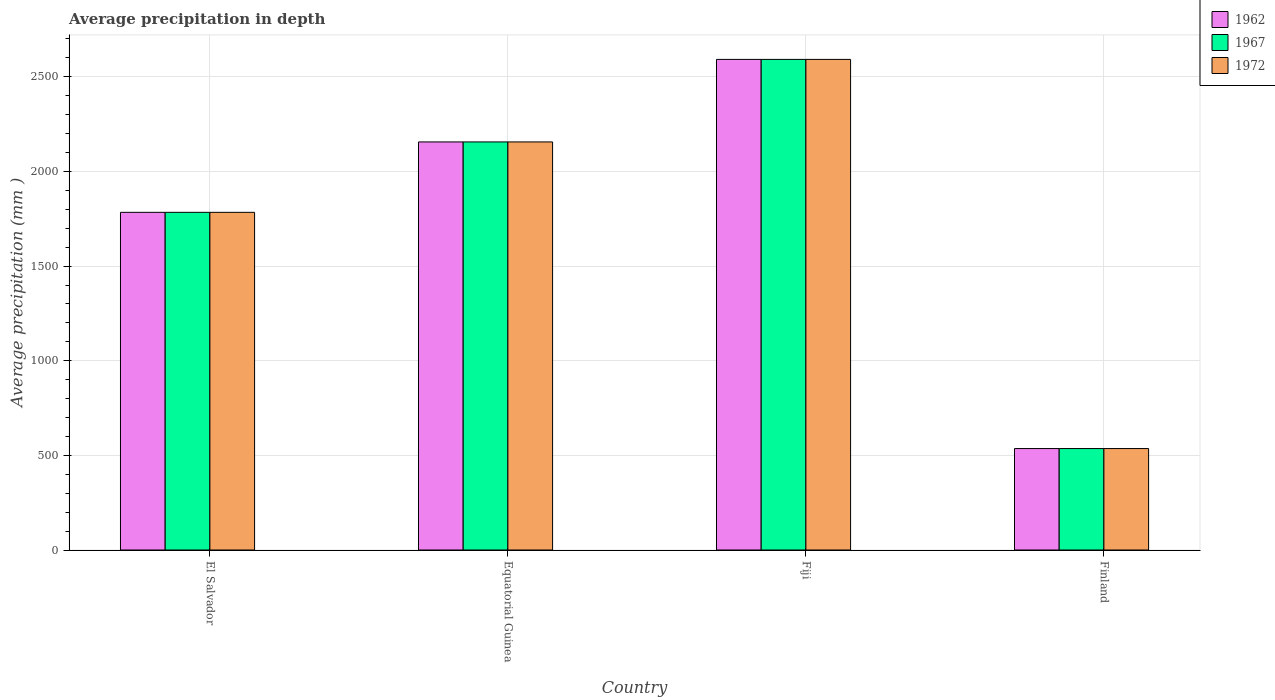How many different coloured bars are there?
Keep it short and to the point. 3. What is the label of the 4th group of bars from the left?
Offer a terse response. Finland. What is the average precipitation in 1972 in El Salvador?
Offer a terse response. 1784. Across all countries, what is the maximum average precipitation in 1962?
Ensure brevity in your answer.  2592. Across all countries, what is the minimum average precipitation in 1972?
Your answer should be compact. 536. In which country was the average precipitation in 1967 maximum?
Provide a succinct answer. Fiji. In which country was the average precipitation in 1962 minimum?
Provide a short and direct response. Finland. What is the total average precipitation in 1967 in the graph?
Offer a terse response. 7068. What is the difference between the average precipitation in 1962 in El Salvador and that in Finland?
Provide a succinct answer. 1248. What is the difference between the average precipitation in 1967 in Fiji and the average precipitation in 1962 in Finland?
Offer a terse response. 2056. What is the average average precipitation in 1972 per country?
Give a very brief answer. 1767. In how many countries, is the average precipitation in 1972 greater than 1400 mm?
Your answer should be very brief. 3. What is the ratio of the average precipitation in 1962 in Equatorial Guinea to that in Finland?
Give a very brief answer. 4.02. Is the difference between the average precipitation in 1967 in Equatorial Guinea and Finland greater than the difference between the average precipitation in 1972 in Equatorial Guinea and Finland?
Keep it short and to the point. No. What is the difference between the highest and the second highest average precipitation in 1972?
Keep it short and to the point. 808. What is the difference between the highest and the lowest average precipitation in 1962?
Your answer should be very brief. 2056. In how many countries, is the average precipitation in 1967 greater than the average average precipitation in 1967 taken over all countries?
Your answer should be compact. 3. What does the 2nd bar from the left in Equatorial Guinea represents?
Offer a terse response. 1967. What does the 3rd bar from the right in Fiji represents?
Your answer should be compact. 1962. Is it the case that in every country, the sum of the average precipitation in 1972 and average precipitation in 1962 is greater than the average precipitation in 1967?
Your response must be concise. Yes. How many bars are there?
Your answer should be very brief. 12. Are the values on the major ticks of Y-axis written in scientific E-notation?
Offer a terse response. No. Does the graph contain any zero values?
Keep it short and to the point. No. Where does the legend appear in the graph?
Your answer should be compact. Top right. How are the legend labels stacked?
Offer a terse response. Vertical. What is the title of the graph?
Offer a very short reply. Average precipitation in depth. What is the label or title of the Y-axis?
Ensure brevity in your answer.  Average precipitation (mm ). What is the Average precipitation (mm ) in 1962 in El Salvador?
Provide a short and direct response. 1784. What is the Average precipitation (mm ) in 1967 in El Salvador?
Make the answer very short. 1784. What is the Average precipitation (mm ) in 1972 in El Salvador?
Your answer should be compact. 1784. What is the Average precipitation (mm ) in 1962 in Equatorial Guinea?
Provide a succinct answer. 2156. What is the Average precipitation (mm ) in 1967 in Equatorial Guinea?
Give a very brief answer. 2156. What is the Average precipitation (mm ) of 1972 in Equatorial Guinea?
Provide a short and direct response. 2156. What is the Average precipitation (mm ) of 1962 in Fiji?
Provide a succinct answer. 2592. What is the Average precipitation (mm ) of 1967 in Fiji?
Your answer should be compact. 2592. What is the Average precipitation (mm ) in 1972 in Fiji?
Give a very brief answer. 2592. What is the Average precipitation (mm ) of 1962 in Finland?
Your answer should be compact. 536. What is the Average precipitation (mm ) in 1967 in Finland?
Make the answer very short. 536. What is the Average precipitation (mm ) of 1972 in Finland?
Your answer should be very brief. 536. Across all countries, what is the maximum Average precipitation (mm ) of 1962?
Ensure brevity in your answer.  2592. Across all countries, what is the maximum Average precipitation (mm ) of 1967?
Provide a succinct answer. 2592. Across all countries, what is the maximum Average precipitation (mm ) in 1972?
Give a very brief answer. 2592. Across all countries, what is the minimum Average precipitation (mm ) of 1962?
Give a very brief answer. 536. Across all countries, what is the minimum Average precipitation (mm ) of 1967?
Your response must be concise. 536. Across all countries, what is the minimum Average precipitation (mm ) in 1972?
Your response must be concise. 536. What is the total Average precipitation (mm ) of 1962 in the graph?
Make the answer very short. 7068. What is the total Average precipitation (mm ) in 1967 in the graph?
Provide a succinct answer. 7068. What is the total Average precipitation (mm ) of 1972 in the graph?
Make the answer very short. 7068. What is the difference between the Average precipitation (mm ) of 1962 in El Salvador and that in Equatorial Guinea?
Keep it short and to the point. -372. What is the difference between the Average precipitation (mm ) in 1967 in El Salvador and that in Equatorial Guinea?
Provide a short and direct response. -372. What is the difference between the Average precipitation (mm ) in 1972 in El Salvador and that in Equatorial Guinea?
Your response must be concise. -372. What is the difference between the Average precipitation (mm ) of 1962 in El Salvador and that in Fiji?
Make the answer very short. -808. What is the difference between the Average precipitation (mm ) in 1967 in El Salvador and that in Fiji?
Ensure brevity in your answer.  -808. What is the difference between the Average precipitation (mm ) in 1972 in El Salvador and that in Fiji?
Give a very brief answer. -808. What is the difference between the Average precipitation (mm ) in 1962 in El Salvador and that in Finland?
Provide a succinct answer. 1248. What is the difference between the Average precipitation (mm ) in 1967 in El Salvador and that in Finland?
Your answer should be compact. 1248. What is the difference between the Average precipitation (mm ) in 1972 in El Salvador and that in Finland?
Make the answer very short. 1248. What is the difference between the Average precipitation (mm ) of 1962 in Equatorial Guinea and that in Fiji?
Make the answer very short. -436. What is the difference between the Average precipitation (mm ) in 1967 in Equatorial Guinea and that in Fiji?
Keep it short and to the point. -436. What is the difference between the Average precipitation (mm ) in 1972 in Equatorial Guinea and that in Fiji?
Provide a short and direct response. -436. What is the difference between the Average precipitation (mm ) of 1962 in Equatorial Guinea and that in Finland?
Provide a short and direct response. 1620. What is the difference between the Average precipitation (mm ) in 1967 in Equatorial Guinea and that in Finland?
Offer a terse response. 1620. What is the difference between the Average precipitation (mm ) in 1972 in Equatorial Guinea and that in Finland?
Give a very brief answer. 1620. What is the difference between the Average precipitation (mm ) in 1962 in Fiji and that in Finland?
Your answer should be very brief. 2056. What is the difference between the Average precipitation (mm ) in 1967 in Fiji and that in Finland?
Provide a succinct answer. 2056. What is the difference between the Average precipitation (mm ) of 1972 in Fiji and that in Finland?
Offer a very short reply. 2056. What is the difference between the Average precipitation (mm ) of 1962 in El Salvador and the Average precipitation (mm ) of 1967 in Equatorial Guinea?
Your response must be concise. -372. What is the difference between the Average precipitation (mm ) of 1962 in El Salvador and the Average precipitation (mm ) of 1972 in Equatorial Guinea?
Ensure brevity in your answer.  -372. What is the difference between the Average precipitation (mm ) in 1967 in El Salvador and the Average precipitation (mm ) in 1972 in Equatorial Guinea?
Make the answer very short. -372. What is the difference between the Average precipitation (mm ) in 1962 in El Salvador and the Average precipitation (mm ) in 1967 in Fiji?
Provide a succinct answer. -808. What is the difference between the Average precipitation (mm ) in 1962 in El Salvador and the Average precipitation (mm ) in 1972 in Fiji?
Your response must be concise. -808. What is the difference between the Average precipitation (mm ) of 1967 in El Salvador and the Average precipitation (mm ) of 1972 in Fiji?
Your answer should be very brief. -808. What is the difference between the Average precipitation (mm ) of 1962 in El Salvador and the Average precipitation (mm ) of 1967 in Finland?
Your response must be concise. 1248. What is the difference between the Average precipitation (mm ) in 1962 in El Salvador and the Average precipitation (mm ) in 1972 in Finland?
Make the answer very short. 1248. What is the difference between the Average precipitation (mm ) in 1967 in El Salvador and the Average precipitation (mm ) in 1972 in Finland?
Give a very brief answer. 1248. What is the difference between the Average precipitation (mm ) of 1962 in Equatorial Guinea and the Average precipitation (mm ) of 1967 in Fiji?
Provide a short and direct response. -436. What is the difference between the Average precipitation (mm ) of 1962 in Equatorial Guinea and the Average precipitation (mm ) of 1972 in Fiji?
Your answer should be very brief. -436. What is the difference between the Average precipitation (mm ) in 1967 in Equatorial Guinea and the Average precipitation (mm ) in 1972 in Fiji?
Your response must be concise. -436. What is the difference between the Average precipitation (mm ) of 1962 in Equatorial Guinea and the Average precipitation (mm ) of 1967 in Finland?
Offer a very short reply. 1620. What is the difference between the Average precipitation (mm ) in 1962 in Equatorial Guinea and the Average precipitation (mm ) in 1972 in Finland?
Keep it short and to the point. 1620. What is the difference between the Average precipitation (mm ) of 1967 in Equatorial Guinea and the Average precipitation (mm ) of 1972 in Finland?
Provide a succinct answer. 1620. What is the difference between the Average precipitation (mm ) of 1962 in Fiji and the Average precipitation (mm ) of 1967 in Finland?
Your answer should be very brief. 2056. What is the difference between the Average precipitation (mm ) in 1962 in Fiji and the Average precipitation (mm ) in 1972 in Finland?
Offer a terse response. 2056. What is the difference between the Average precipitation (mm ) of 1967 in Fiji and the Average precipitation (mm ) of 1972 in Finland?
Keep it short and to the point. 2056. What is the average Average precipitation (mm ) of 1962 per country?
Ensure brevity in your answer.  1767. What is the average Average precipitation (mm ) in 1967 per country?
Offer a terse response. 1767. What is the average Average precipitation (mm ) of 1972 per country?
Your response must be concise. 1767. What is the difference between the Average precipitation (mm ) in 1962 and Average precipitation (mm ) in 1972 in El Salvador?
Keep it short and to the point. 0. What is the difference between the Average precipitation (mm ) of 1962 and Average precipitation (mm ) of 1967 in Equatorial Guinea?
Provide a short and direct response. 0. What is the difference between the Average precipitation (mm ) in 1962 and Average precipitation (mm ) in 1972 in Equatorial Guinea?
Offer a terse response. 0. What is the difference between the Average precipitation (mm ) in 1962 and Average precipitation (mm ) in 1967 in Fiji?
Your answer should be very brief. 0. What is the difference between the Average precipitation (mm ) of 1967 and Average precipitation (mm ) of 1972 in Fiji?
Make the answer very short. 0. What is the difference between the Average precipitation (mm ) of 1962 and Average precipitation (mm ) of 1972 in Finland?
Ensure brevity in your answer.  0. What is the difference between the Average precipitation (mm ) of 1967 and Average precipitation (mm ) of 1972 in Finland?
Keep it short and to the point. 0. What is the ratio of the Average precipitation (mm ) in 1962 in El Salvador to that in Equatorial Guinea?
Keep it short and to the point. 0.83. What is the ratio of the Average precipitation (mm ) of 1967 in El Salvador to that in Equatorial Guinea?
Keep it short and to the point. 0.83. What is the ratio of the Average precipitation (mm ) of 1972 in El Salvador to that in Equatorial Guinea?
Keep it short and to the point. 0.83. What is the ratio of the Average precipitation (mm ) of 1962 in El Salvador to that in Fiji?
Offer a very short reply. 0.69. What is the ratio of the Average precipitation (mm ) in 1967 in El Salvador to that in Fiji?
Make the answer very short. 0.69. What is the ratio of the Average precipitation (mm ) in 1972 in El Salvador to that in Fiji?
Provide a succinct answer. 0.69. What is the ratio of the Average precipitation (mm ) in 1962 in El Salvador to that in Finland?
Your response must be concise. 3.33. What is the ratio of the Average precipitation (mm ) in 1967 in El Salvador to that in Finland?
Offer a very short reply. 3.33. What is the ratio of the Average precipitation (mm ) in 1972 in El Salvador to that in Finland?
Make the answer very short. 3.33. What is the ratio of the Average precipitation (mm ) in 1962 in Equatorial Guinea to that in Fiji?
Ensure brevity in your answer.  0.83. What is the ratio of the Average precipitation (mm ) in 1967 in Equatorial Guinea to that in Fiji?
Keep it short and to the point. 0.83. What is the ratio of the Average precipitation (mm ) in 1972 in Equatorial Guinea to that in Fiji?
Your answer should be very brief. 0.83. What is the ratio of the Average precipitation (mm ) in 1962 in Equatorial Guinea to that in Finland?
Your answer should be very brief. 4.02. What is the ratio of the Average precipitation (mm ) in 1967 in Equatorial Guinea to that in Finland?
Offer a very short reply. 4.02. What is the ratio of the Average precipitation (mm ) in 1972 in Equatorial Guinea to that in Finland?
Offer a very short reply. 4.02. What is the ratio of the Average precipitation (mm ) in 1962 in Fiji to that in Finland?
Provide a short and direct response. 4.84. What is the ratio of the Average precipitation (mm ) of 1967 in Fiji to that in Finland?
Your answer should be compact. 4.84. What is the ratio of the Average precipitation (mm ) in 1972 in Fiji to that in Finland?
Ensure brevity in your answer.  4.84. What is the difference between the highest and the second highest Average precipitation (mm ) of 1962?
Keep it short and to the point. 436. What is the difference between the highest and the second highest Average precipitation (mm ) in 1967?
Offer a very short reply. 436. What is the difference between the highest and the second highest Average precipitation (mm ) in 1972?
Your answer should be very brief. 436. What is the difference between the highest and the lowest Average precipitation (mm ) in 1962?
Your answer should be compact. 2056. What is the difference between the highest and the lowest Average precipitation (mm ) of 1967?
Your answer should be compact. 2056. What is the difference between the highest and the lowest Average precipitation (mm ) in 1972?
Provide a succinct answer. 2056. 